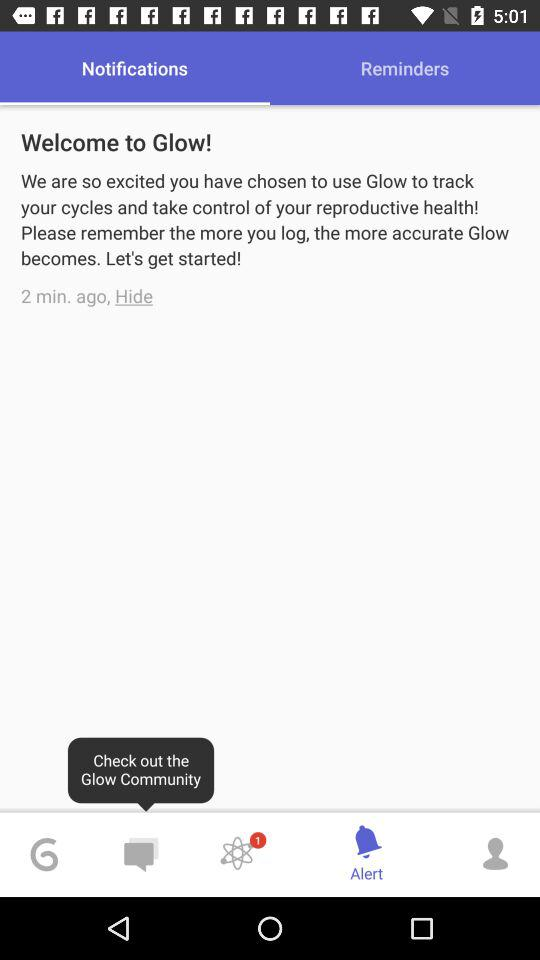What is the name of the application? The name of the application is "Glow". 